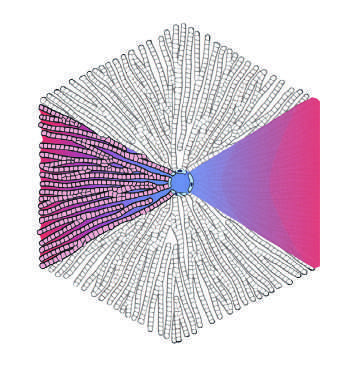what is at the center of a lobule, while the portal tracts are at the periphery in the lobular model?
Answer the question using a single word or phrase. The terminal hepatic vein 